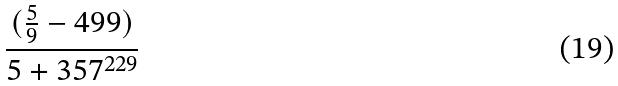<formula> <loc_0><loc_0><loc_500><loc_500>\frac { ( \frac { 5 } { 9 } - 4 9 9 ) } { 5 + 3 5 7 ^ { 2 2 9 } }</formula> 